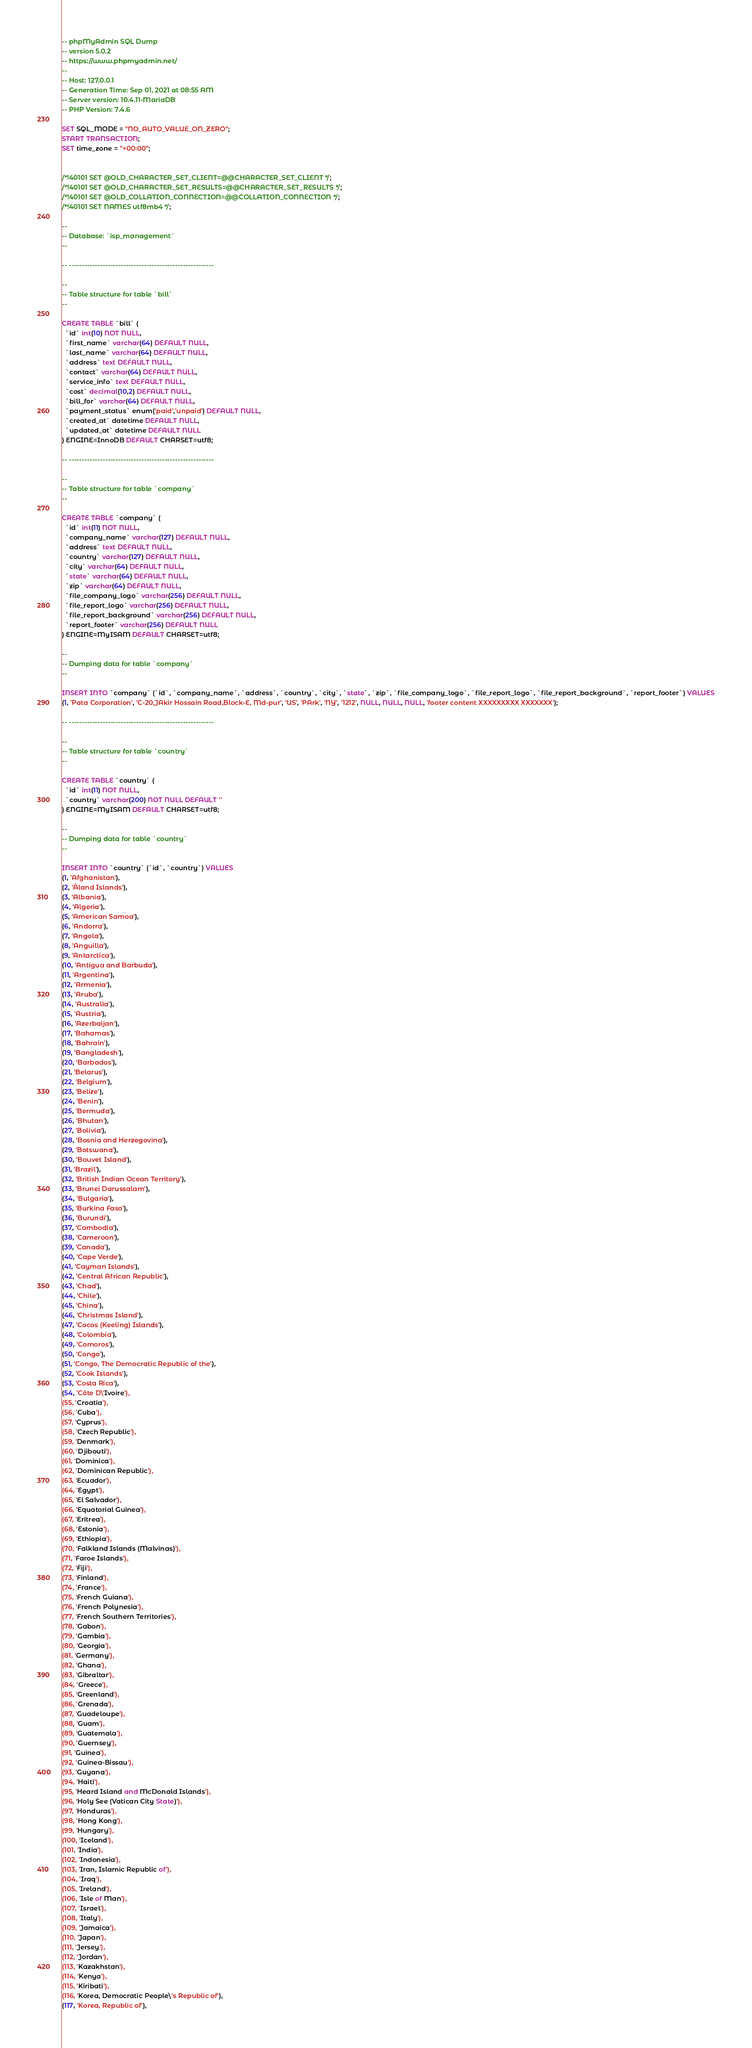<code> <loc_0><loc_0><loc_500><loc_500><_SQL_>-- phpMyAdmin SQL Dump
-- version 5.0.2
-- https://www.phpmyadmin.net/
--
-- Host: 127.0.0.1
-- Generation Time: Sep 01, 2021 at 08:55 AM
-- Server version: 10.4.11-MariaDB
-- PHP Version: 7.4.6

SET SQL_MODE = "NO_AUTO_VALUE_ON_ZERO";
START TRANSACTION;
SET time_zone = "+00:00";


/*!40101 SET @OLD_CHARACTER_SET_CLIENT=@@CHARACTER_SET_CLIENT */;
/*!40101 SET @OLD_CHARACTER_SET_RESULTS=@@CHARACTER_SET_RESULTS */;
/*!40101 SET @OLD_COLLATION_CONNECTION=@@COLLATION_CONNECTION */;
/*!40101 SET NAMES utf8mb4 */;

--
-- Database: `isp_management`
--

-- --------------------------------------------------------

--
-- Table structure for table `bill`
--

CREATE TABLE `bill` (
  `id` int(10) NOT NULL,
  `first_name` varchar(64) DEFAULT NULL,
  `last_name` varchar(64) DEFAULT NULL,
  `address` text DEFAULT NULL,
  `contact` varchar(64) DEFAULT NULL,
  `service_info` text DEFAULT NULL,
  `cost` decimal(10,2) DEFAULT NULL,
  `bill_for` varchar(64) DEFAULT NULL,
  `payment_status` enum('paid','unpaid') DEFAULT NULL,
  `created_at` datetime DEFAULT NULL,
  `updated_at` datetime DEFAULT NULL
) ENGINE=InnoDB DEFAULT CHARSET=utf8;

-- --------------------------------------------------------

--
-- Table structure for table `company`
--

CREATE TABLE `company` (
  `id` int(11) NOT NULL,
  `company_name` varchar(127) DEFAULT NULL,
  `address` text DEFAULT NULL,
  `country` varchar(127) DEFAULT NULL,
  `city` varchar(64) DEFAULT NULL,
  `state` varchar(64) DEFAULT NULL,
  `zip` varchar(64) DEFAULT NULL,
  `file_company_logo` varchar(256) DEFAULT NULL,
  `file_report_logo` varchar(256) DEFAULT NULL,
  `file_report_background` varchar(256) DEFAULT NULL,
  `report_footer` varchar(256) DEFAULT NULL
) ENGINE=MyISAM DEFAULT CHARSET=utf8;

--
-- Dumping data for table `company`
--

INSERT INTO `company` (`id`, `company_name`, `address`, `country`, `city`, `state`, `zip`, `file_company_logo`, `file_report_logo`, `file_report_background`, `report_footer`) VALUES
(1, 'Pata Corporation', 'C-20,JAkir Hossain Road,Block-E, Md-pur', 'US', 'PArk', 'NY', '1212', NULL, NULL, NULL, 'footer content XXXXXXXXX XXXXXXX');

-- --------------------------------------------------------

--
-- Table structure for table `country`
--

CREATE TABLE `country` (
  `id` int(11) NOT NULL,
  `country` varchar(200) NOT NULL DEFAULT ''
) ENGINE=MyISAM DEFAULT CHARSET=utf8;

--
-- Dumping data for table `country`
--

INSERT INTO `country` (`id`, `country`) VALUES
(1, 'Afghanistan'),
(2, 'Åland Islands'),
(3, 'Albania'),
(4, 'Algeria'),
(5, 'American Samoa'),
(6, 'Andorra'),
(7, 'Angola'),
(8, 'Anguilla'),
(9, 'Antarctica'),
(10, 'Antigua and Barbuda'),
(11, 'Argentina'),
(12, 'Armenia'),
(13, 'Aruba'),
(14, 'Australia'),
(15, 'Austria'),
(16, 'Azerbaijan'),
(17, 'Bahamas'),
(18, 'Bahrain'),
(19, 'Bangladesh'),
(20, 'Barbados'),
(21, 'Belarus'),
(22, 'Belgium'),
(23, 'Belize'),
(24, 'Benin'),
(25, 'Bermuda'),
(26, 'Bhutan'),
(27, 'Bolivia'),
(28, 'Bosnia and Herzegovina'),
(29, 'Botswana'),
(30, 'Bouvet Island'),
(31, 'Brazil'),
(32, 'British Indian Ocean Territory'),
(33, 'Brunei Darussalam'),
(34, 'Bulgaria'),
(35, 'Burkina Faso'),
(36, 'Burundi'),
(37, 'Cambodia'),
(38, 'Cameroon'),
(39, 'Canada'),
(40, 'Cape Verde'),
(41, 'Cayman Islands'),
(42, 'Central African Republic'),
(43, 'Chad'),
(44, 'Chile'),
(45, 'China'),
(46, 'Christmas Island'),
(47, 'Cocos (Keeling) Islands'),
(48, 'Colombia'),
(49, 'Comoros'),
(50, 'Congo'),
(51, 'Congo, The Democratic Republic of the'),
(52, 'Cook Islands'),
(53, 'Costa Rica'),
(54, 'Côte D\'Ivoire'),
(55, 'Croatia'),
(56, 'Cuba'),
(57, 'Cyprus'),
(58, 'Czech Republic'),
(59, 'Denmark'),
(60, 'Djibouti'),
(61, 'Dominica'),
(62, 'Dominican Republic'),
(63, 'Ecuador'),
(64, 'Egypt'),
(65, 'El Salvador'),
(66, 'Equatorial Guinea'),
(67, 'Eritrea'),
(68, 'Estonia'),
(69, 'Ethiopia'),
(70, 'Falkland Islands (Malvinas)'),
(71, 'Faroe Islands'),
(72, 'Fiji'),
(73, 'Finland'),
(74, 'France'),
(75, 'French Guiana'),
(76, 'French Polynesia'),
(77, 'French Southern Territories'),
(78, 'Gabon'),
(79, 'Gambia'),
(80, 'Georgia'),
(81, 'Germany'),
(82, 'Ghana'),
(83, 'Gibraltar'),
(84, 'Greece'),
(85, 'Greenland'),
(86, 'Grenada'),
(87, 'Guadeloupe'),
(88, 'Guam'),
(89, 'Guatemala'),
(90, 'Guernsey'),
(91, 'Guinea'),
(92, 'Guinea-Bissau'),
(93, 'Guyana'),
(94, 'Haiti'),
(95, 'Heard Island and McDonald Islands'),
(96, 'Holy See (Vatican City State)'),
(97, 'Honduras'),
(98, 'Hong Kong'),
(99, 'Hungary'),
(100, 'Iceland'),
(101, 'India'),
(102, 'Indonesia'),
(103, 'Iran, Islamic Republic of'),
(104, 'Iraq'),
(105, 'Ireland'),
(106, 'Isle of Man'),
(107, 'Israel'),
(108, 'Italy'),
(109, 'Jamaica'),
(110, 'Japan'),
(111, 'Jersey'),
(112, 'Jordan'),
(113, 'Kazakhstan'),
(114, 'Kenya'),
(115, 'Kiribati'),
(116, 'Korea, Democratic People\'s Republic of'),
(117, 'Korea, Republic of'),</code> 